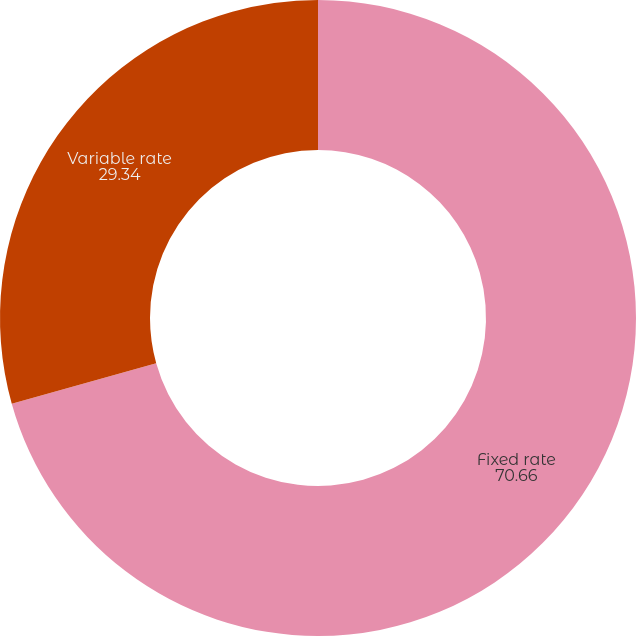Convert chart. <chart><loc_0><loc_0><loc_500><loc_500><pie_chart><fcel>Fixed rate<fcel>Variable rate<nl><fcel>70.66%<fcel>29.34%<nl></chart> 